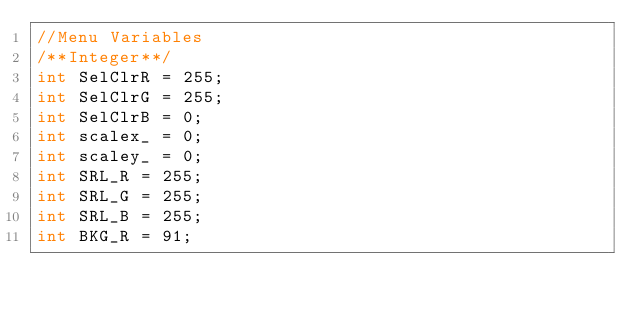<code> <loc_0><loc_0><loc_500><loc_500><_C_>//Menu Variables
/**Integer**/
int SelClrR = 255;
int SelClrG = 255;
int SelClrB = 0;
int scalex_ = 0;
int scaley_ = 0;
int SRL_R = 255;
int SRL_G = 255;
int SRL_B = 255;
int BKG_R = 91;</code> 